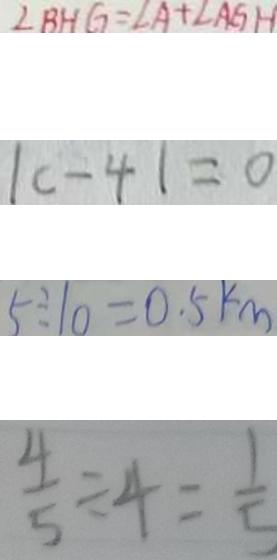<formula> <loc_0><loc_0><loc_500><loc_500>\angle B H G = \angle A + \angle A G H 
 \vert c - 4 \vert = 0 
 5 \div 1 0 = 0 . 5 k m 
 \frac { 4 } { 5 } \div 4 = \frac { 1 } { 5 }</formula> 